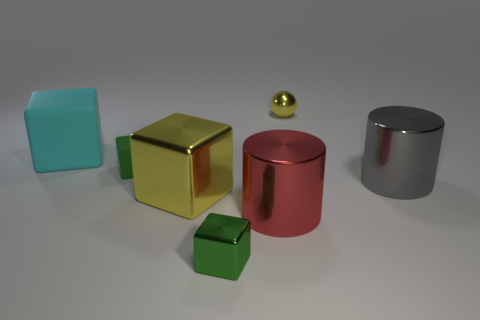Is the size of the green metal block the same as the cylinder that is in front of the large metal cube?
Provide a succinct answer. No. What number of small objects are green matte things or cyan things?
Provide a short and direct response. 1. Is the number of big green metal cylinders greater than the number of large red objects?
Keep it short and to the point. No. There is a small block in front of the yellow metallic object that is in front of the small ball; what number of yellow blocks are left of it?
Make the answer very short. 1. What is the shape of the small rubber thing?
Your answer should be very brief. Cube. How many other things are the same material as the large cyan thing?
Your response must be concise. 1. Do the green metal object and the green rubber object have the same size?
Give a very brief answer. Yes. What shape is the green object in front of the big yellow cube?
Make the answer very short. Cube. There is a big cylinder that is to the right of the yellow object behind the big gray metallic cylinder; what color is it?
Provide a short and direct response. Gray. Is the shape of the green thing behind the large yellow shiny block the same as the yellow object behind the big gray cylinder?
Keep it short and to the point. No. 